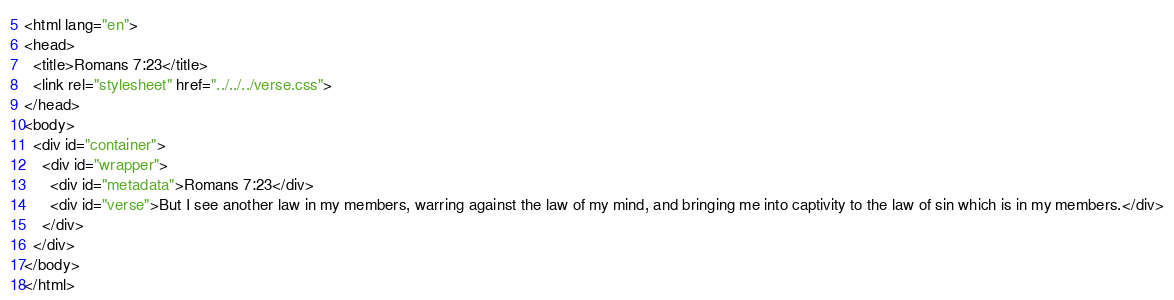Convert code to text. <code><loc_0><loc_0><loc_500><loc_500><_HTML_><html lang="en">
<head>
  <title>Romans 7:23</title>
  <link rel="stylesheet" href="../../../verse.css">
</head>
<body>
  <div id="container">
    <div id="wrapper">
      <div id="metadata">Romans 7:23</div>
      <div id="verse">But I see another law in my members, warring against the law of my mind, and bringing me into captivity to the law of sin which is in my members.</div>
    </div>
  </div>
</body>
</html></code> 